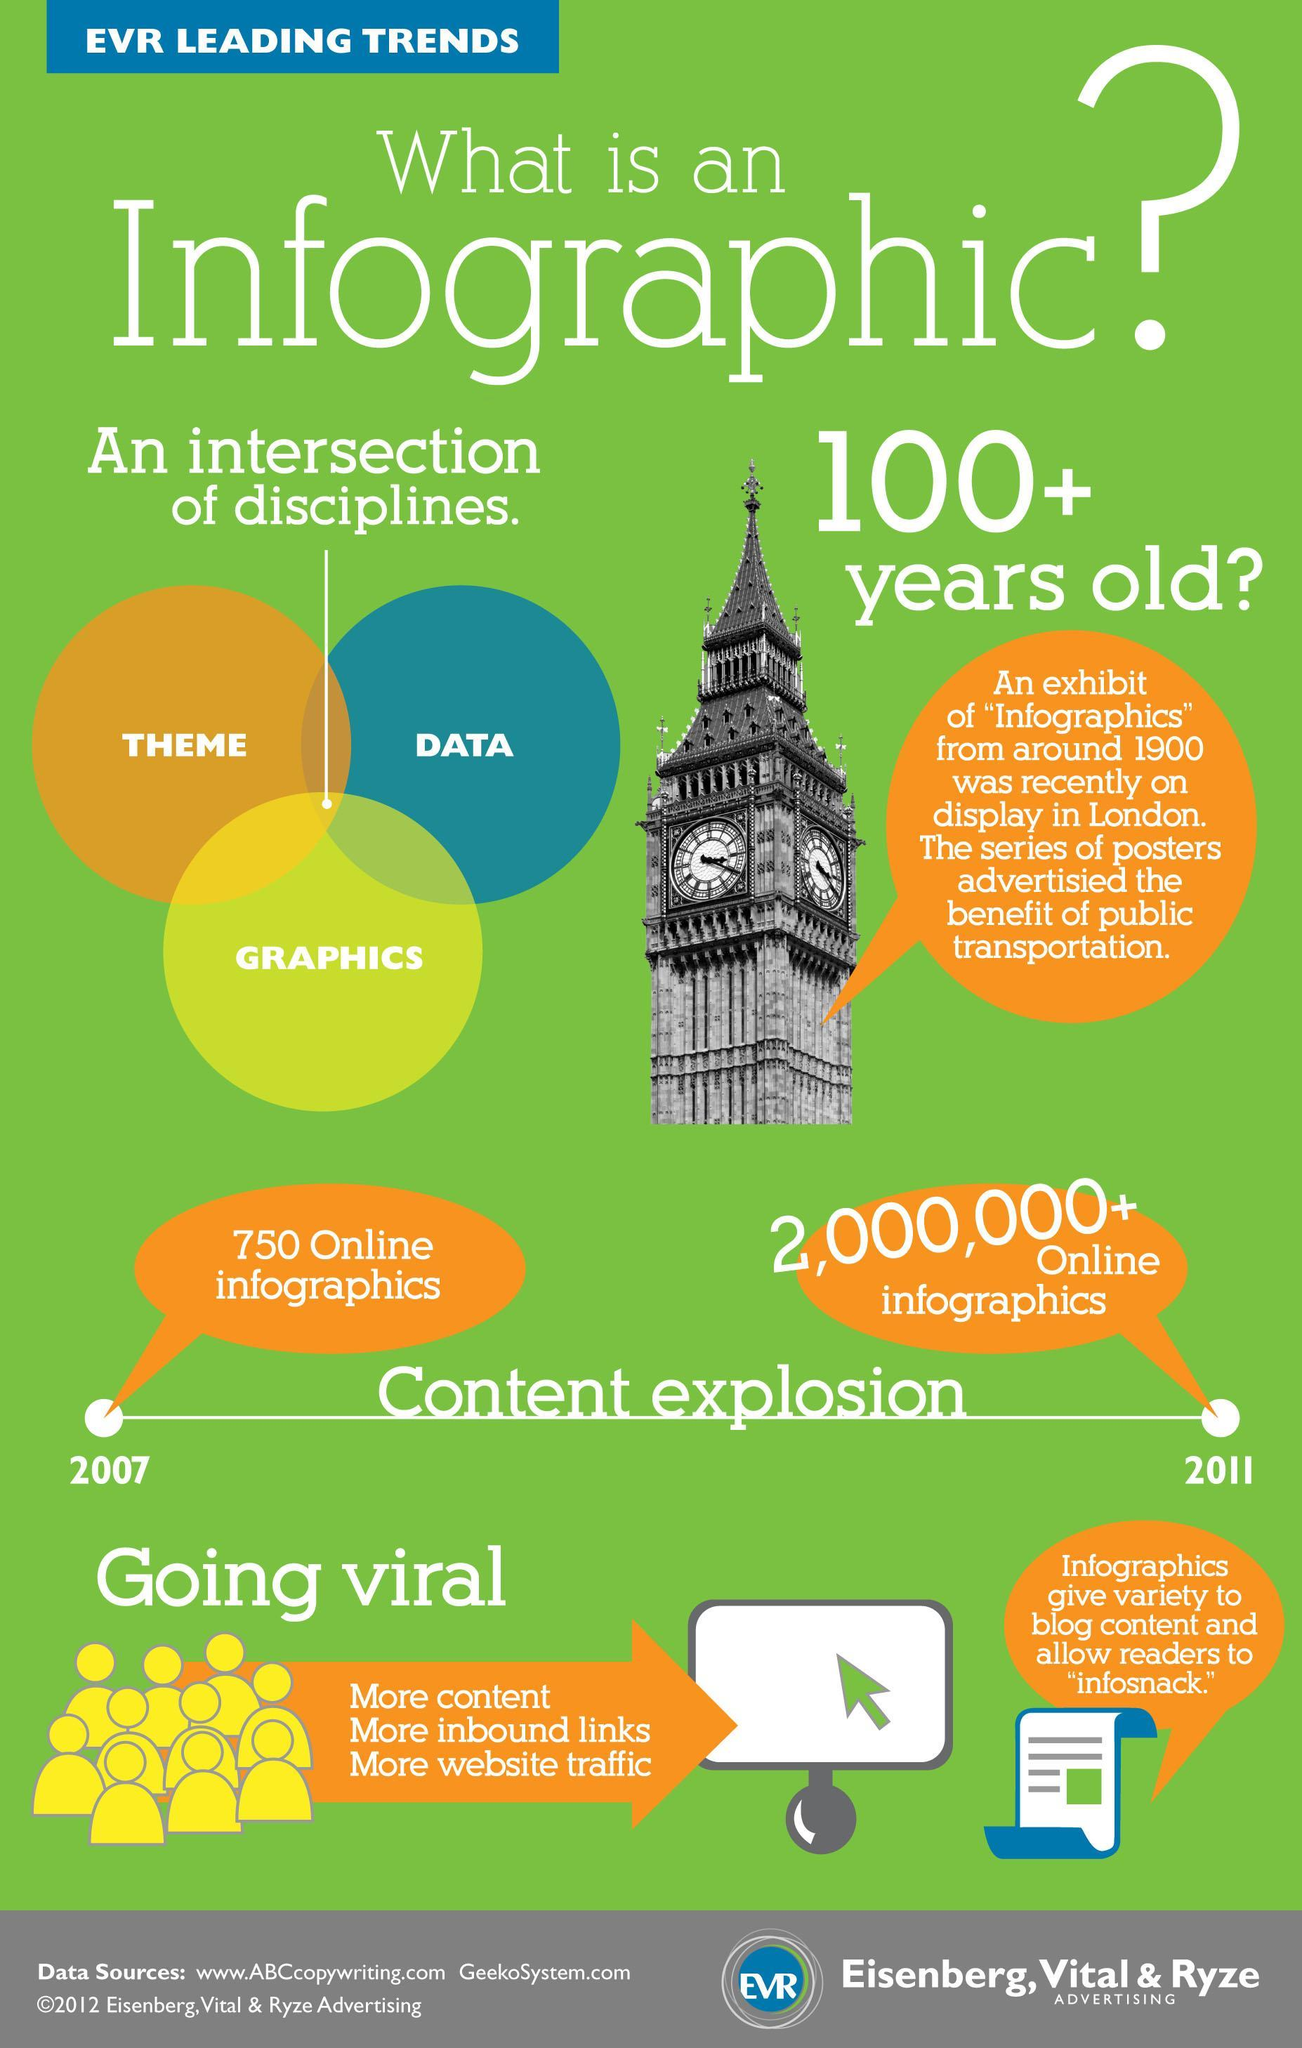Which color denotes the discipline graphics, orange, blue, or yellow?
Answer the question with a short phrase. yellow 